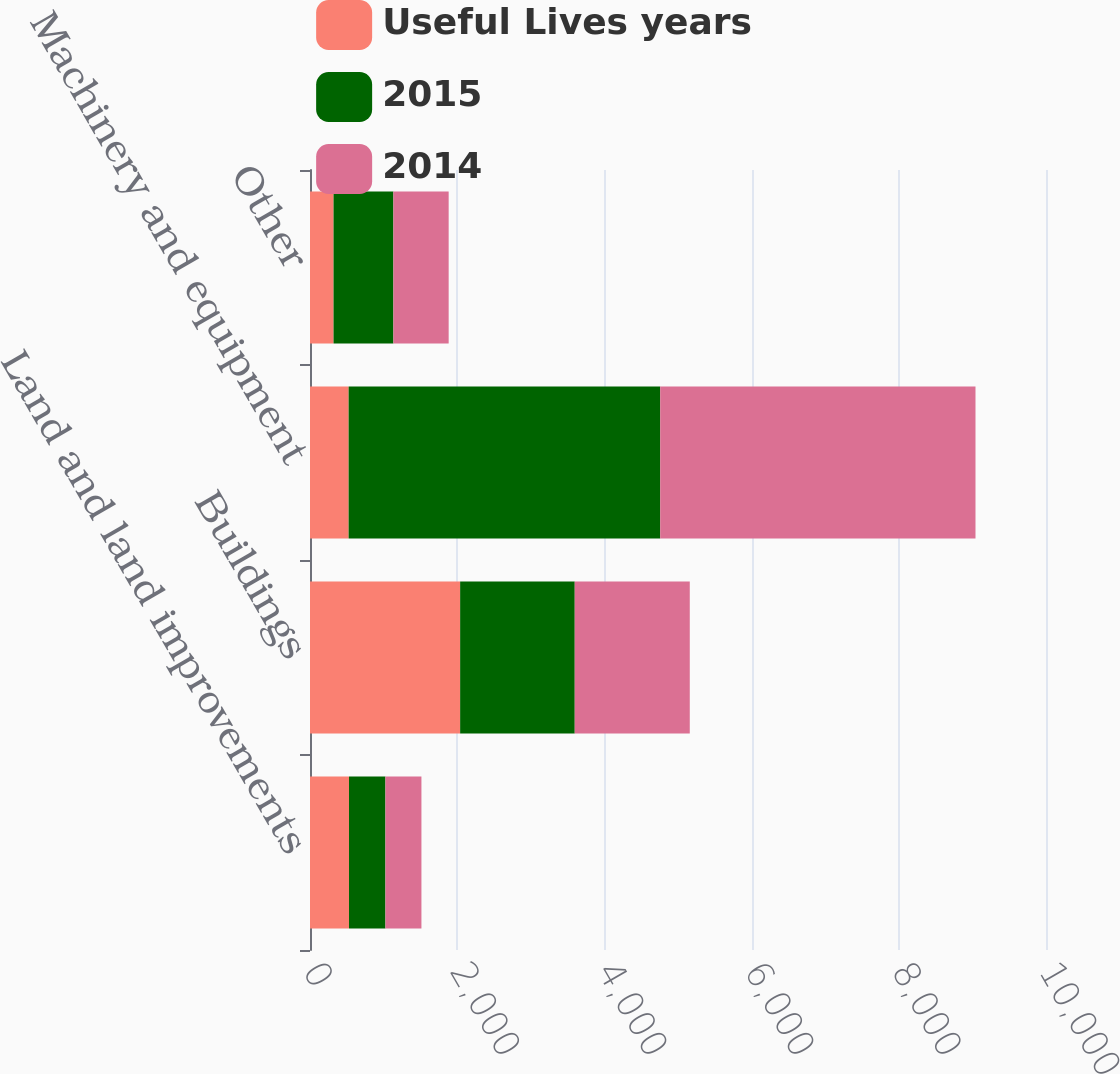Convert chart to OTSL. <chart><loc_0><loc_0><loc_500><loc_500><stacked_bar_chart><ecel><fcel>Land and land improvements<fcel>Buildings<fcel>Machinery and equipment<fcel>Other<nl><fcel>Useful Lives years<fcel>530<fcel>2040<fcel>525<fcel>320<nl><fcel>2015<fcel>495<fcel>1557<fcel>4233<fcel>813<nl><fcel>2014<fcel>489<fcel>1563<fcel>4284<fcel>751<nl></chart> 